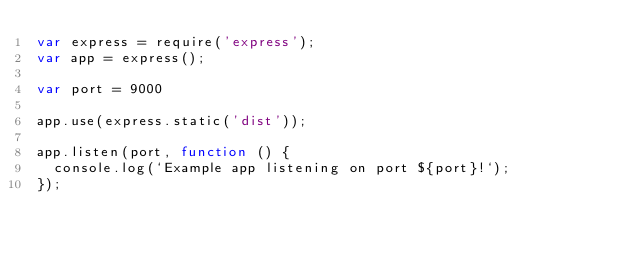<code> <loc_0><loc_0><loc_500><loc_500><_JavaScript_>var express = require('express');
var app = express();

var port = 9000

app.use(express.static('dist'));

app.listen(port, function () {
  console.log(`Example app listening on port ${port}!`);
});</code> 